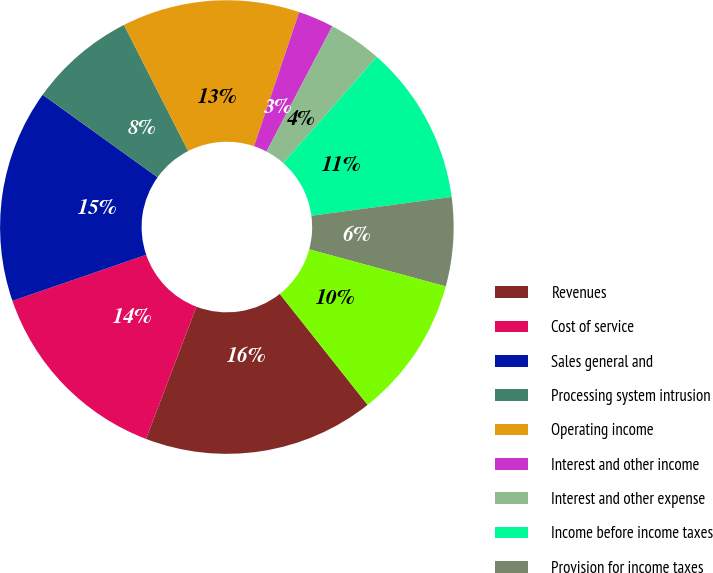Convert chart. <chart><loc_0><loc_0><loc_500><loc_500><pie_chart><fcel>Revenues<fcel>Cost of service<fcel>Sales general and<fcel>Processing system intrusion<fcel>Operating income<fcel>Interest and other income<fcel>Interest and other expense<fcel>Income before income taxes<fcel>Provision for income taxes<fcel>Net income<nl><fcel>16.46%<fcel>13.92%<fcel>15.19%<fcel>7.59%<fcel>12.66%<fcel>2.53%<fcel>3.8%<fcel>11.39%<fcel>6.33%<fcel>10.13%<nl></chart> 